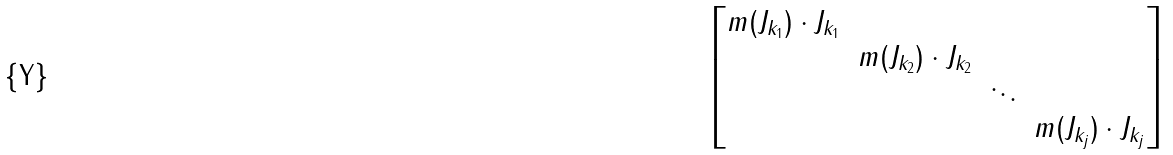Convert formula to latex. <formula><loc_0><loc_0><loc_500><loc_500>\begin{bmatrix} m ( J _ { k _ { 1 } } ) \cdot J _ { k _ { 1 } } \\ & m ( J _ { k _ { 2 } } ) \cdot J _ { k _ { 2 } } \\ & & \ddots \\ & & & m ( J _ { k _ { j } } ) \cdot J _ { k _ { j } } \end{bmatrix}</formula> 